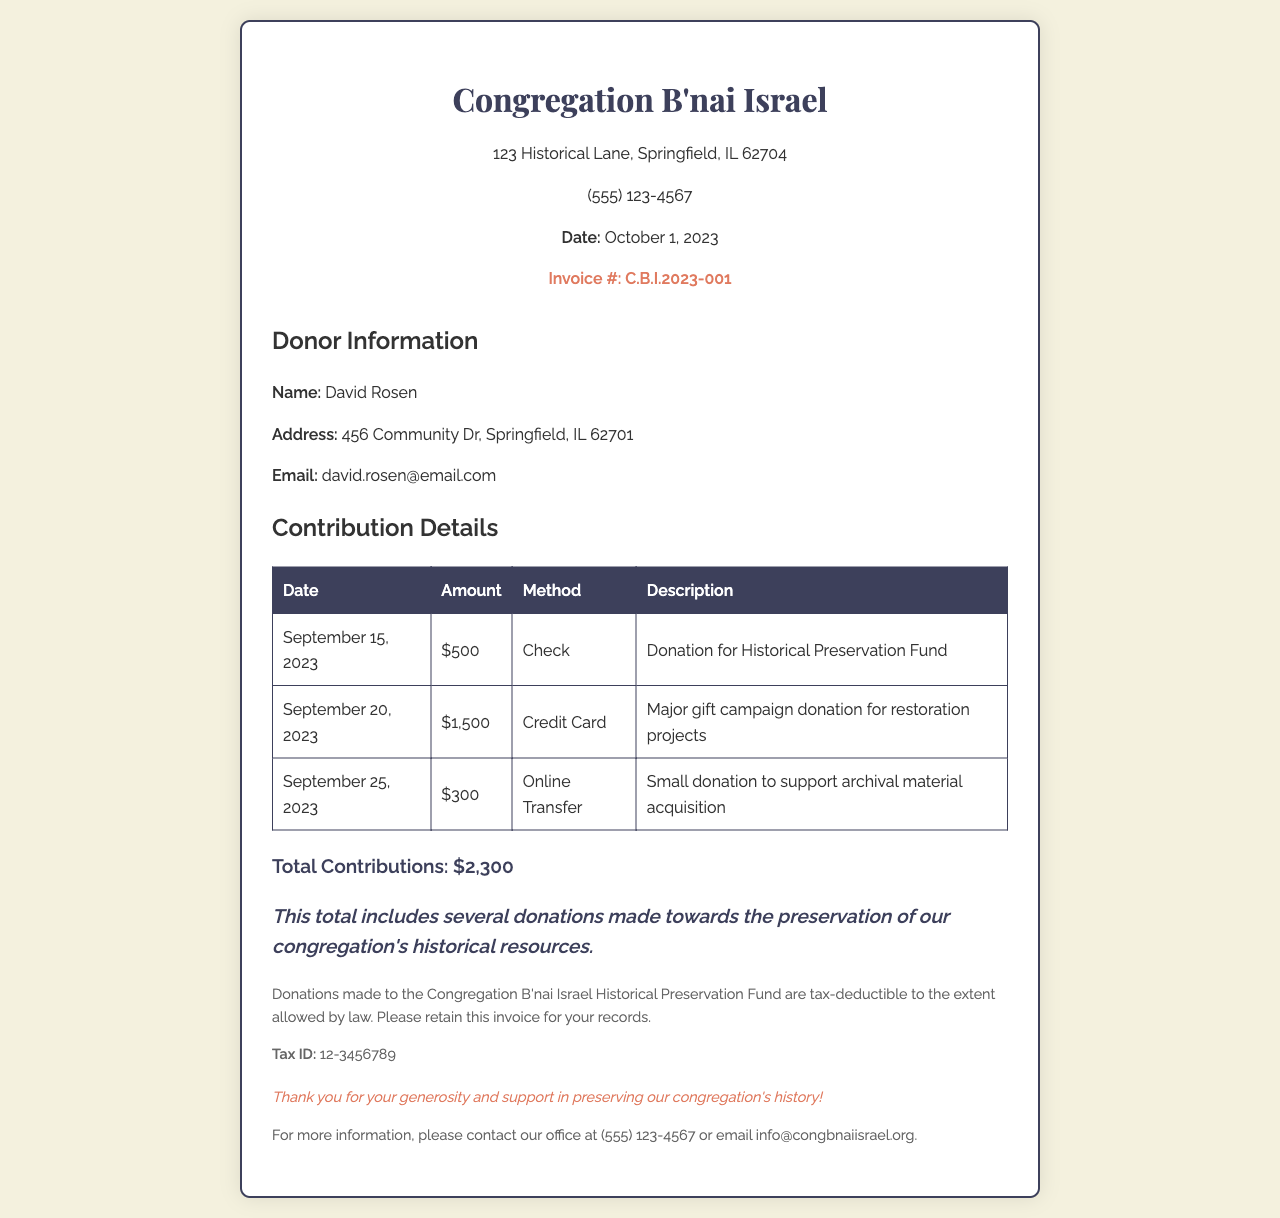What is the name of the donor? The donor's name is listed in the donor information section of the document.
Answer: David Rosen What is the total amount of contributions? The total contributions are calculated based on the amounts listed in the contribution details section.
Answer: $2,300 What method was used for the donation on September 20, 2023? The method of donation is specified in the contribution details table.
Answer: Credit Card What is the tax ID of the Congregation? The tax ID is mentioned in the tax information section of the invoice.
Answer: 12-3456789 What was the description of the donation made on September 25, 2023? Each donation provides a description that can be found in the contribution details table.
Answer: Small donation to support archival material acquisition How many donations are listed in the contribution details? The number of donations refers to the rows presented in the contribution details table.
Answer: 3 